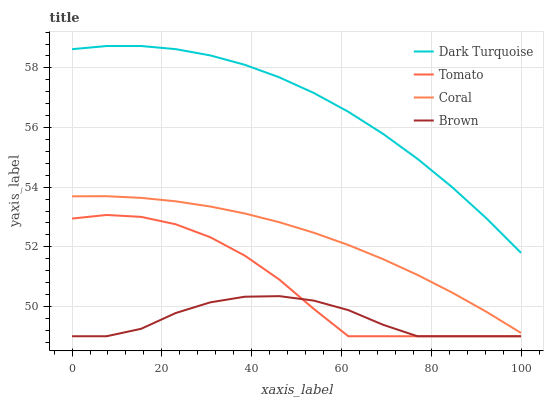Does Brown have the minimum area under the curve?
Answer yes or no. Yes. Does Dark Turquoise have the maximum area under the curve?
Answer yes or no. Yes. Does Coral have the minimum area under the curve?
Answer yes or no. No. Does Coral have the maximum area under the curve?
Answer yes or no. No. Is Coral the smoothest?
Answer yes or no. Yes. Is Tomato the roughest?
Answer yes or no. Yes. Is Dark Turquoise the smoothest?
Answer yes or no. No. Is Dark Turquoise the roughest?
Answer yes or no. No. Does Tomato have the lowest value?
Answer yes or no. Yes. Does Coral have the lowest value?
Answer yes or no. No. Does Dark Turquoise have the highest value?
Answer yes or no. Yes. Does Coral have the highest value?
Answer yes or no. No. Is Brown less than Dark Turquoise?
Answer yes or no. Yes. Is Dark Turquoise greater than Brown?
Answer yes or no. Yes. Does Tomato intersect Brown?
Answer yes or no. Yes. Is Tomato less than Brown?
Answer yes or no. No. Is Tomato greater than Brown?
Answer yes or no. No. Does Brown intersect Dark Turquoise?
Answer yes or no. No. 